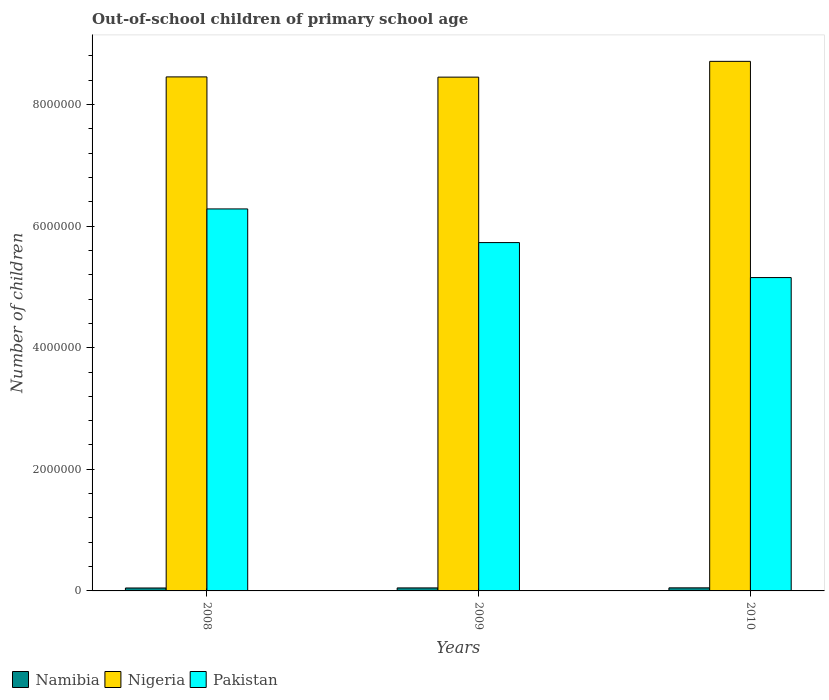How many groups of bars are there?
Make the answer very short. 3. Are the number of bars per tick equal to the number of legend labels?
Ensure brevity in your answer.  Yes. How many bars are there on the 1st tick from the left?
Offer a terse response. 3. What is the label of the 1st group of bars from the left?
Your answer should be very brief. 2008. What is the number of out-of-school children in Pakistan in 2008?
Provide a succinct answer. 6.28e+06. Across all years, what is the maximum number of out-of-school children in Namibia?
Your answer should be very brief. 5.06e+04. Across all years, what is the minimum number of out-of-school children in Nigeria?
Your answer should be very brief. 8.45e+06. In which year was the number of out-of-school children in Namibia minimum?
Keep it short and to the point. 2008. What is the total number of out-of-school children in Pakistan in the graph?
Your answer should be very brief. 1.72e+07. What is the difference between the number of out-of-school children in Nigeria in 2009 and that in 2010?
Your response must be concise. -2.59e+05. What is the difference between the number of out-of-school children in Nigeria in 2008 and the number of out-of-school children in Namibia in 2010?
Offer a terse response. 8.40e+06. What is the average number of out-of-school children in Nigeria per year?
Offer a very short reply. 8.54e+06. In the year 2010, what is the difference between the number of out-of-school children in Nigeria and number of out-of-school children in Namibia?
Make the answer very short. 8.66e+06. In how many years, is the number of out-of-school children in Pakistan greater than 5600000?
Provide a succinct answer. 2. What is the ratio of the number of out-of-school children in Pakistan in 2008 to that in 2009?
Ensure brevity in your answer.  1.1. Is the number of out-of-school children in Namibia in 2008 less than that in 2010?
Make the answer very short. Yes. What is the difference between the highest and the second highest number of out-of-school children in Pakistan?
Your answer should be very brief. 5.54e+05. What is the difference between the highest and the lowest number of out-of-school children in Nigeria?
Your answer should be compact. 2.59e+05. In how many years, is the number of out-of-school children in Nigeria greater than the average number of out-of-school children in Nigeria taken over all years?
Give a very brief answer. 1. Is the sum of the number of out-of-school children in Namibia in 2008 and 2009 greater than the maximum number of out-of-school children in Nigeria across all years?
Provide a short and direct response. No. What does the 2nd bar from the left in 2010 represents?
Ensure brevity in your answer.  Nigeria. What does the 3rd bar from the right in 2009 represents?
Offer a terse response. Namibia. How many bars are there?
Your response must be concise. 9. How many years are there in the graph?
Offer a very short reply. 3. What is the difference between two consecutive major ticks on the Y-axis?
Provide a succinct answer. 2.00e+06. Are the values on the major ticks of Y-axis written in scientific E-notation?
Your answer should be very brief. No. Does the graph contain grids?
Your answer should be compact. No. Where does the legend appear in the graph?
Your answer should be very brief. Bottom left. How are the legend labels stacked?
Keep it short and to the point. Horizontal. What is the title of the graph?
Provide a succinct answer. Out-of-school children of primary school age. Does "Vietnam" appear as one of the legend labels in the graph?
Offer a terse response. No. What is the label or title of the Y-axis?
Your response must be concise. Number of children. What is the Number of children in Namibia in 2008?
Offer a very short reply. 4.82e+04. What is the Number of children in Nigeria in 2008?
Your answer should be very brief. 8.45e+06. What is the Number of children of Pakistan in 2008?
Offer a terse response. 6.28e+06. What is the Number of children in Namibia in 2009?
Make the answer very short. 4.95e+04. What is the Number of children of Nigeria in 2009?
Keep it short and to the point. 8.45e+06. What is the Number of children of Pakistan in 2009?
Give a very brief answer. 5.73e+06. What is the Number of children in Namibia in 2010?
Make the answer very short. 5.06e+04. What is the Number of children of Nigeria in 2010?
Your response must be concise. 8.71e+06. What is the Number of children of Pakistan in 2010?
Your response must be concise. 5.15e+06. Across all years, what is the maximum Number of children of Namibia?
Provide a succinct answer. 5.06e+04. Across all years, what is the maximum Number of children of Nigeria?
Provide a short and direct response. 8.71e+06. Across all years, what is the maximum Number of children of Pakistan?
Your answer should be very brief. 6.28e+06. Across all years, what is the minimum Number of children in Namibia?
Give a very brief answer. 4.82e+04. Across all years, what is the minimum Number of children of Nigeria?
Your answer should be compact. 8.45e+06. Across all years, what is the minimum Number of children in Pakistan?
Provide a succinct answer. 5.15e+06. What is the total Number of children of Namibia in the graph?
Offer a terse response. 1.48e+05. What is the total Number of children of Nigeria in the graph?
Offer a terse response. 2.56e+07. What is the total Number of children of Pakistan in the graph?
Ensure brevity in your answer.  1.72e+07. What is the difference between the Number of children of Namibia in 2008 and that in 2009?
Offer a terse response. -1240. What is the difference between the Number of children of Nigeria in 2008 and that in 2009?
Your answer should be very brief. 3838. What is the difference between the Number of children of Pakistan in 2008 and that in 2009?
Your response must be concise. 5.54e+05. What is the difference between the Number of children of Namibia in 2008 and that in 2010?
Give a very brief answer. -2372. What is the difference between the Number of children of Nigeria in 2008 and that in 2010?
Make the answer very short. -2.56e+05. What is the difference between the Number of children of Pakistan in 2008 and that in 2010?
Make the answer very short. 1.13e+06. What is the difference between the Number of children in Namibia in 2009 and that in 2010?
Give a very brief answer. -1132. What is the difference between the Number of children of Nigeria in 2009 and that in 2010?
Offer a very short reply. -2.59e+05. What is the difference between the Number of children in Pakistan in 2009 and that in 2010?
Keep it short and to the point. 5.75e+05. What is the difference between the Number of children of Namibia in 2008 and the Number of children of Nigeria in 2009?
Your response must be concise. -8.40e+06. What is the difference between the Number of children of Namibia in 2008 and the Number of children of Pakistan in 2009?
Give a very brief answer. -5.68e+06. What is the difference between the Number of children of Nigeria in 2008 and the Number of children of Pakistan in 2009?
Your answer should be very brief. 2.72e+06. What is the difference between the Number of children in Namibia in 2008 and the Number of children in Nigeria in 2010?
Keep it short and to the point. -8.66e+06. What is the difference between the Number of children in Namibia in 2008 and the Number of children in Pakistan in 2010?
Ensure brevity in your answer.  -5.11e+06. What is the difference between the Number of children of Nigeria in 2008 and the Number of children of Pakistan in 2010?
Your answer should be compact. 3.30e+06. What is the difference between the Number of children in Namibia in 2009 and the Number of children in Nigeria in 2010?
Provide a succinct answer. -8.66e+06. What is the difference between the Number of children of Namibia in 2009 and the Number of children of Pakistan in 2010?
Ensure brevity in your answer.  -5.10e+06. What is the difference between the Number of children of Nigeria in 2009 and the Number of children of Pakistan in 2010?
Your answer should be very brief. 3.30e+06. What is the average Number of children in Namibia per year?
Your answer should be compact. 4.94e+04. What is the average Number of children of Nigeria per year?
Ensure brevity in your answer.  8.54e+06. What is the average Number of children of Pakistan per year?
Offer a very short reply. 5.72e+06. In the year 2008, what is the difference between the Number of children of Namibia and Number of children of Nigeria?
Provide a succinct answer. -8.41e+06. In the year 2008, what is the difference between the Number of children in Namibia and Number of children in Pakistan?
Your response must be concise. -6.23e+06. In the year 2008, what is the difference between the Number of children of Nigeria and Number of children of Pakistan?
Provide a short and direct response. 2.17e+06. In the year 2009, what is the difference between the Number of children of Namibia and Number of children of Nigeria?
Provide a succinct answer. -8.40e+06. In the year 2009, what is the difference between the Number of children of Namibia and Number of children of Pakistan?
Your answer should be very brief. -5.68e+06. In the year 2009, what is the difference between the Number of children in Nigeria and Number of children in Pakistan?
Your answer should be compact. 2.72e+06. In the year 2010, what is the difference between the Number of children of Namibia and Number of children of Nigeria?
Provide a succinct answer. -8.66e+06. In the year 2010, what is the difference between the Number of children of Namibia and Number of children of Pakistan?
Your answer should be compact. -5.10e+06. In the year 2010, what is the difference between the Number of children in Nigeria and Number of children in Pakistan?
Ensure brevity in your answer.  3.56e+06. What is the ratio of the Number of children of Namibia in 2008 to that in 2009?
Keep it short and to the point. 0.97. What is the ratio of the Number of children of Nigeria in 2008 to that in 2009?
Ensure brevity in your answer.  1. What is the ratio of the Number of children of Pakistan in 2008 to that in 2009?
Ensure brevity in your answer.  1.1. What is the ratio of the Number of children of Namibia in 2008 to that in 2010?
Give a very brief answer. 0.95. What is the ratio of the Number of children of Nigeria in 2008 to that in 2010?
Your answer should be very brief. 0.97. What is the ratio of the Number of children of Pakistan in 2008 to that in 2010?
Offer a very short reply. 1.22. What is the ratio of the Number of children of Namibia in 2009 to that in 2010?
Provide a succinct answer. 0.98. What is the ratio of the Number of children of Nigeria in 2009 to that in 2010?
Your response must be concise. 0.97. What is the ratio of the Number of children in Pakistan in 2009 to that in 2010?
Make the answer very short. 1.11. What is the difference between the highest and the second highest Number of children of Namibia?
Your answer should be compact. 1132. What is the difference between the highest and the second highest Number of children of Nigeria?
Your answer should be very brief. 2.56e+05. What is the difference between the highest and the second highest Number of children in Pakistan?
Give a very brief answer. 5.54e+05. What is the difference between the highest and the lowest Number of children in Namibia?
Your answer should be very brief. 2372. What is the difference between the highest and the lowest Number of children in Nigeria?
Your response must be concise. 2.59e+05. What is the difference between the highest and the lowest Number of children in Pakistan?
Your response must be concise. 1.13e+06. 